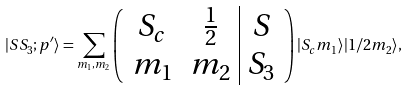<formula> <loc_0><loc_0><loc_500><loc_500>| S S _ { 3 } ; p ^ { \prime } \rangle = \sum _ { m _ { 1 } , m _ { 2 } } \left ( \begin{array} { c c | c } S _ { c } & \frac { 1 } { 2 } & S \\ m _ { 1 } & m _ { 2 } & S _ { 3 } \end{array} \right ) | S _ { c } m _ { 1 } \rangle | 1 / 2 m _ { 2 } \rangle ,</formula> 